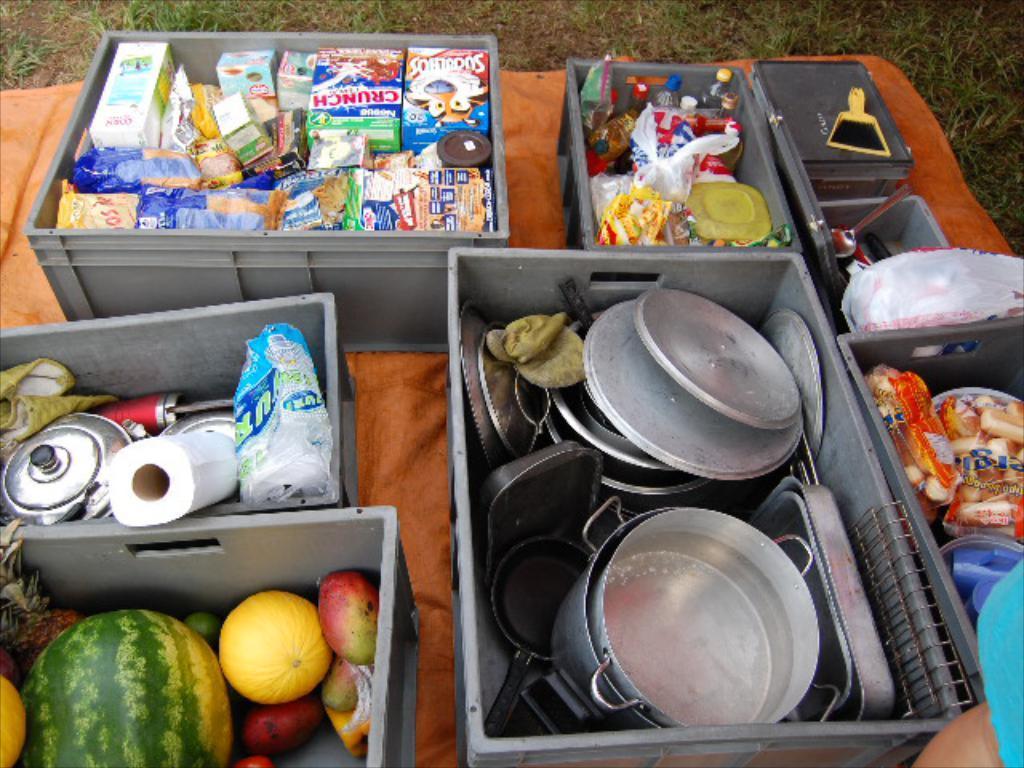Describe this image in one or two sentences. In this image I can see few utensils, vegetables and few food items in the gray color baskets and the baskets are on the orange color cloth. In the background the grass is in green color. 